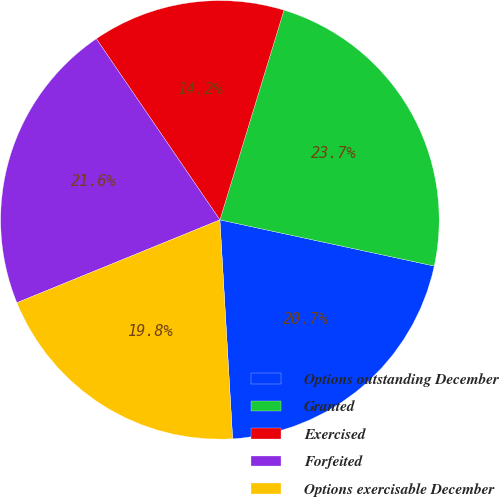Convert chart to OTSL. <chart><loc_0><loc_0><loc_500><loc_500><pie_chart><fcel>Options outstanding December<fcel>Granted<fcel>Exercised<fcel>Forfeited<fcel>Options exercisable December<nl><fcel>20.7%<fcel>23.66%<fcel>14.25%<fcel>21.64%<fcel>19.76%<nl></chart> 